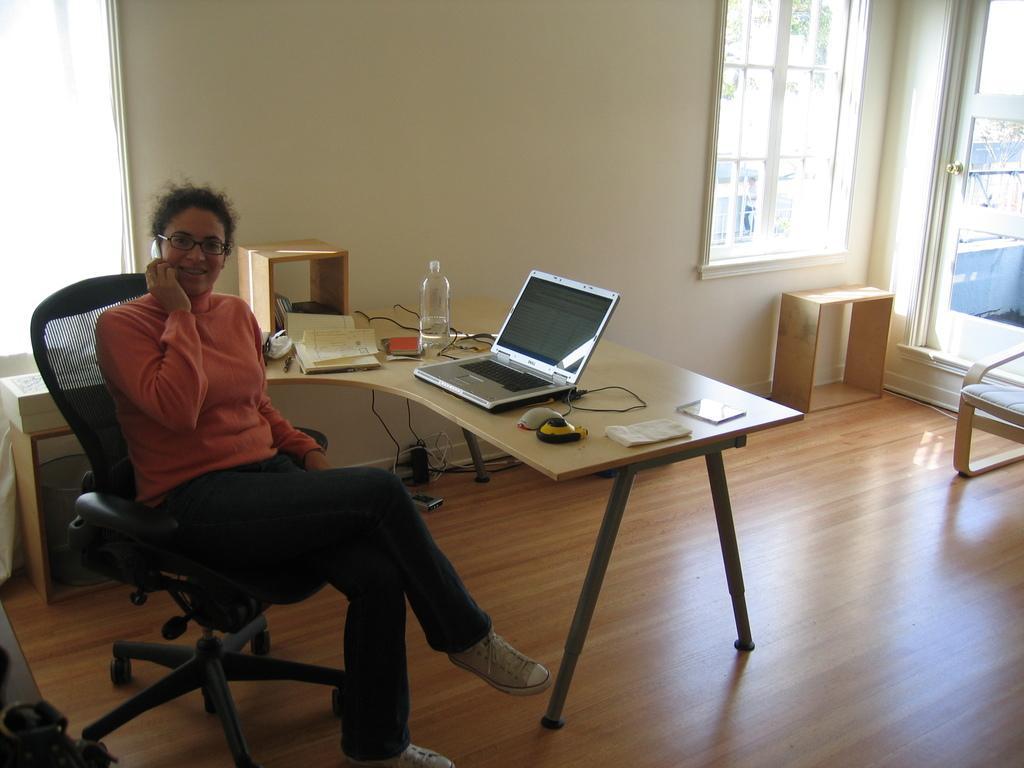In one or two sentences, can you explain what this image depicts? there is a woman sitting in a chair is talking in a mobile phone behind her there is a table with the laptop water bottle and book in it. 